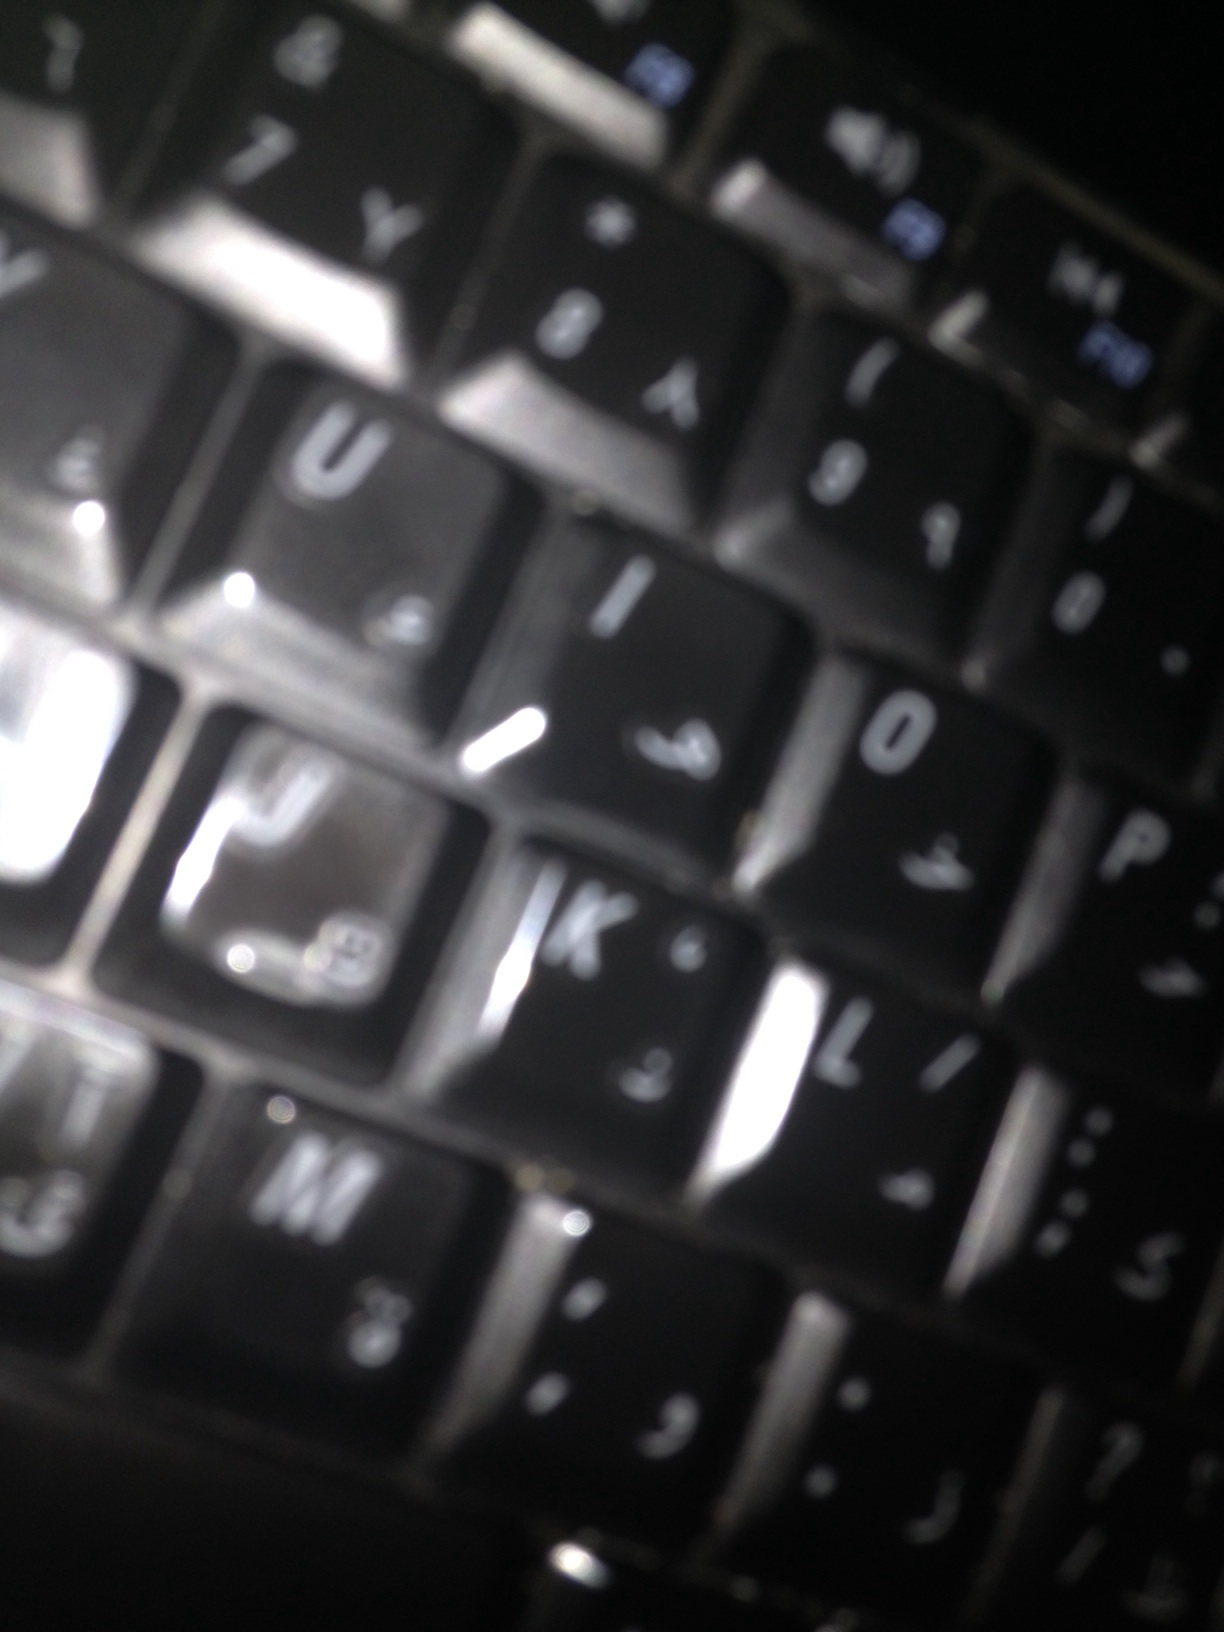Is it a book? No, the image does not depict a book. Instead, it shows a close-up view of a keyboard. The keys on the keyboard are clearly visible. 